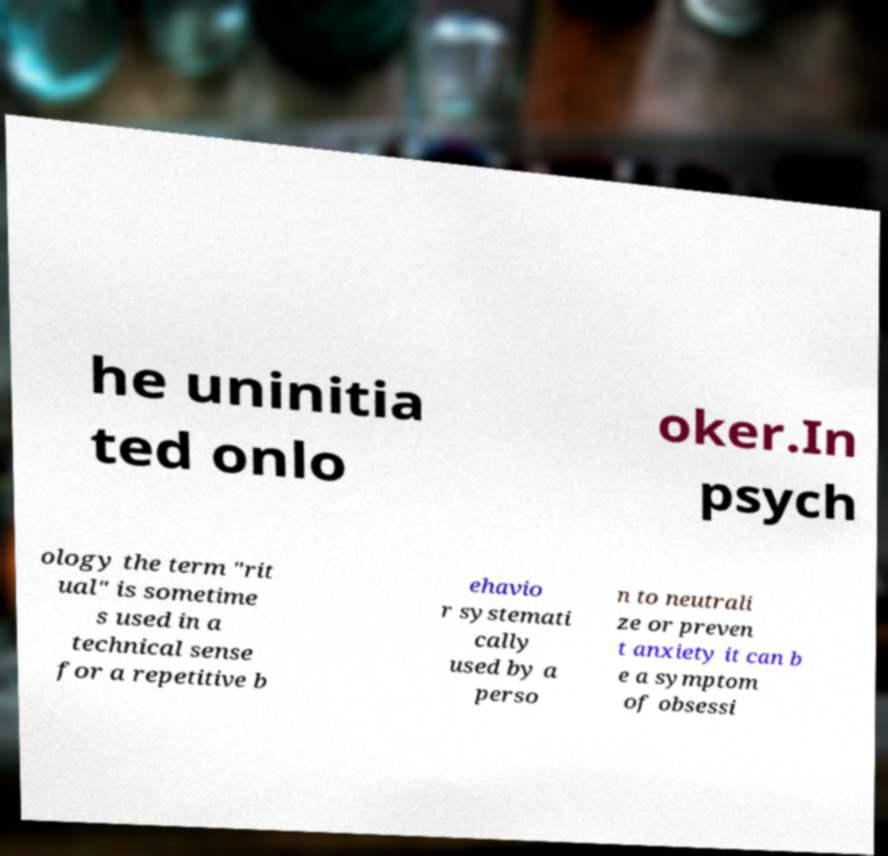I need the written content from this picture converted into text. Can you do that? he uninitia ted onlo oker.In psych ology the term "rit ual" is sometime s used in a technical sense for a repetitive b ehavio r systemati cally used by a perso n to neutrali ze or preven t anxiety it can b e a symptom of obsessi 